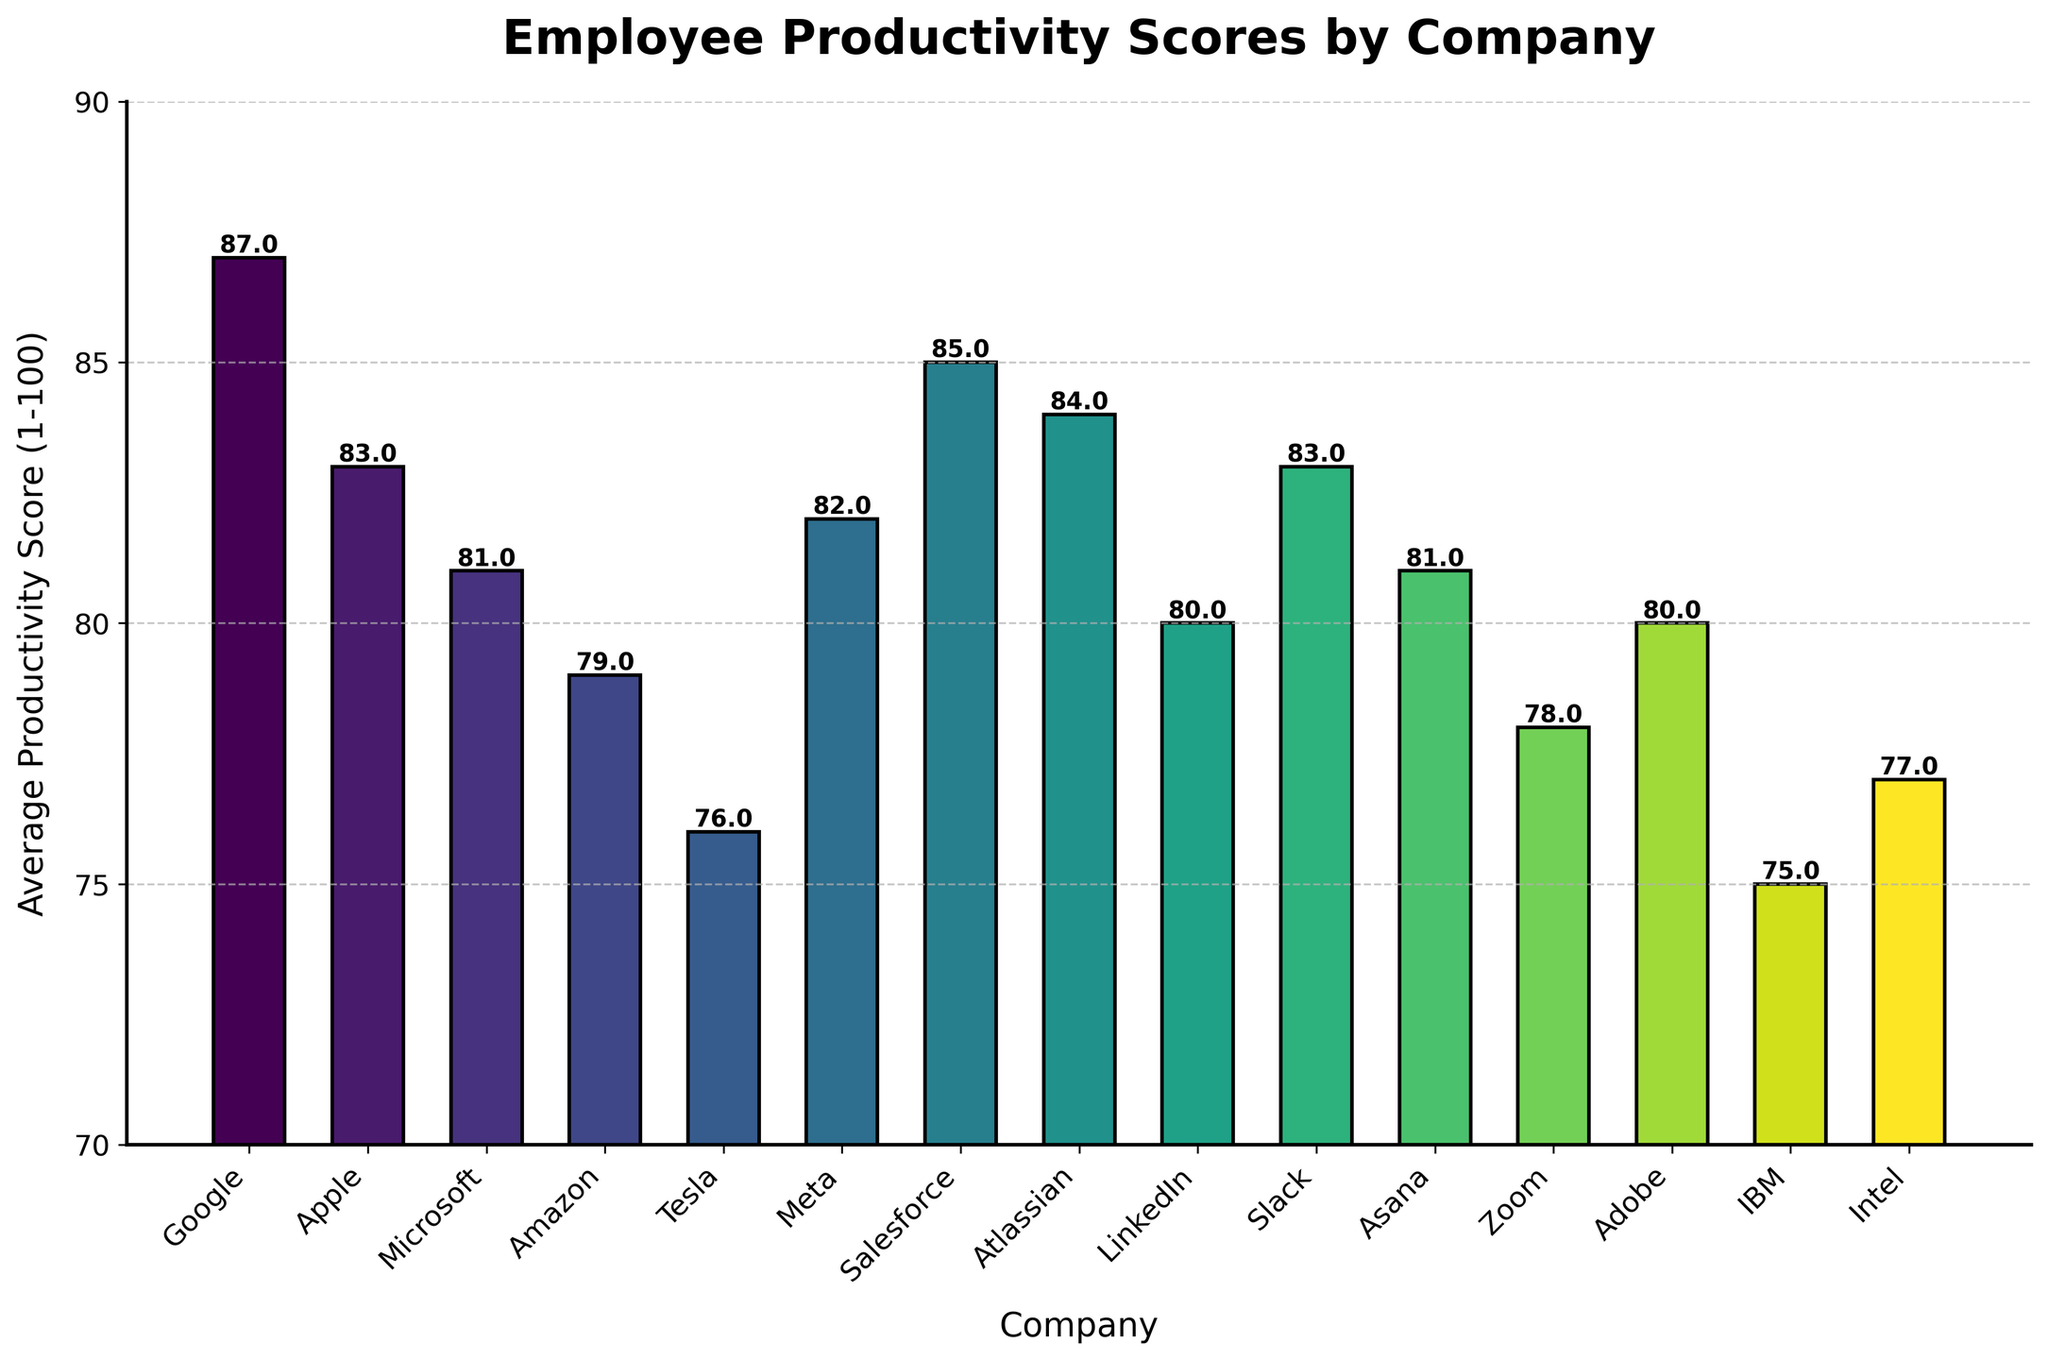What is the company with the highest productivity score? The bar chart shows the productivity scores of various companies, and the tallest bar represents the highest score. Google has the highest productivity score of 87.
Answer: Google Which companies have an average productivity score greater than 80? Looking at the bars for scores above 80, the companies are Google, Apple, Microsoft, Meta, Salesforce, Atlassian, Slack, and Asana.
Answer: Google, Apple, Microsoft, Meta, Salesforce, Atlassian, Slack, Asana What is the range of the productivity scores? The range is found by subtracting the lowest score from the highest score. The lowest score is 75 (IBM) and the highest score is 87 (Google). 87 - 75 gives a range of 12.
Answer: 12 Compare the average productivity score of Tesla and Asana. Which one is higher? By comparing the heights of the bars for Tesla and Asana, Tesla has a score of 76 and Asana has a score of 81. Thus, Asana's score is higher.
Answer: Asana Which company has a productivity score closest to the median score? To find the median, we need to order all scores and find the middle value. The sorted scores are: 75, 76, 77, 78, 79, 80, 80, 81, 81, 82, 83, 83, 84, 85, 87. The median is the 8th value in this sorted list, which is 81, and the companies with this score are Microsoft and Asana.
Answer: Microsoft, Asana How many companies have productivity scores between 70 and 80 (inclusive)? Count the bars with height representing scores between 70 and 80. These companies are Microsoft, Zoom, Adobe, Intel, and IBM. There are five such companies.
Answer: 5 Which company has the third highest productivity score? By inspecting the bars from highest to third highest, the companies in descending order are Google (87), Salesforce (85), and Atlassian (84).
Answer: Atlassian How does LinkedIn’s productivity score compare to Amazon’s? Comparing the bars for LinkedIn and Amazon, LinkedIn has a score of 80 and Amazon has a score of 79. LinkedIn’s score is higher by 1 point.
Answer: LinkedIn’s score is higher What is the mean score of all companies? Sum all the productivity scores and divide by the number of companies: (87 + 83 + 81 + 79 + 76 + 82 + 85 + 84 + 80 + 83 + 81 + 78 + 80 + 75 + 77) / 15 = 1231 / 15 ≈ 82.1.
Answer: 82.1 Which two companies have the largest difference in productivity scores, and what is that difference? Identify the highest (Google, 87) and lowest (IBM, 75) scores, then subtract the latter from the former: 87 - 75 = 12.
Answer: Google and IBM, 12 